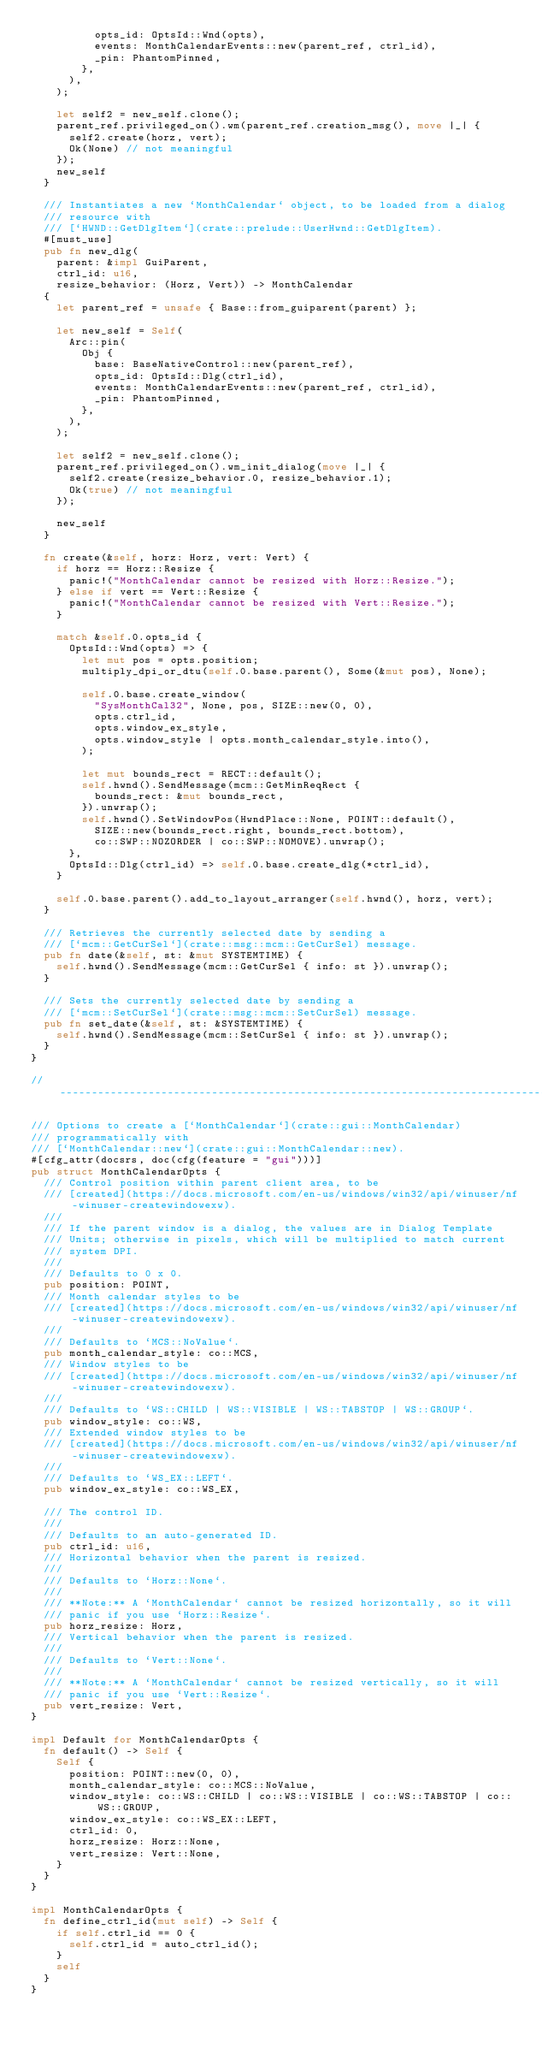<code> <loc_0><loc_0><loc_500><loc_500><_Rust_>					opts_id: OptsId::Wnd(opts),
					events: MonthCalendarEvents::new(parent_ref, ctrl_id),
					_pin: PhantomPinned,
				},
			),
		);

		let self2 = new_self.clone();
		parent_ref.privileged_on().wm(parent_ref.creation_msg(), move |_| {
			self2.create(horz, vert);
			Ok(None) // not meaningful
		});
		new_self
	}

	/// Instantiates a new `MonthCalendar` object, to be loaded from a dialog
	/// resource with
	/// [`HWND::GetDlgItem`](crate::prelude::UserHwnd::GetDlgItem).
	#[must_use]
	pub fn new_dlg(
		parent: &impl GuiParent,
		ctrl_id: u16,
		resize_behavior: (Horz, Vert)) -> MonthCalendar
	{
		let parent_ref = unsafe { Base::from_guiparent(parent) };

		let new_self = Self(
			Arc::pin(
				Obj {
					base: BaseNativeControl::new(parent_ref),
					opts_id: OptsId::Dlg(ctrl_id),
					events: MonthCalendarEvents::new(parent_ref, ctrl_id),
					_pin: PhantomPinned,
				},
			),
		);

		let self2 = new_self.clone();
		parent_ref.privileged_on().wm_init_dialog(move |_| {
			self2.create(resize_behavior.0, resize_behavior.1);
			Ok(true) // not meaningful
		});

		new_self
	}

	fn create(&self, horz: Horz, vert: Vert) {
		if horz == Horz::Resize {
			panic!("MonthCalendar cannot be resized with Horz::Resize.");
		} else if vert == Vert::Resize {
			panic!("MonthCalendar cannot be resized with Vert::Resize.");
		}

		match &self.0.opts_id {
			OptsId::Wnd(opts) => {
				let mut pos = opts.position;
				multiply_dpi_or_dtu(self.0.base.parent(), Some(&mut pos), None);

				self.0.base.create_window(
					"SysMonthCal32", None, pos, SIZE::new(0, 0),
					opts.ctrl_id,
					opts.window_ex_style,
					opts.window_style | opts.month_calendar_style.into(),
				);

				let mut bounds_rect = RECT::default();
				self.hwnd().SendMessage(mcm::GetMinReqRect {
					bounds_rect: &mut bounds_rect,
				}).unwrap();
				self.hwnd().SetWindowPos(HwndPlace::None, POINT::default(),
					SIZE::new(bounds_rect.right, bounds_rect.bottom),
					co::SWP::NOZORDER | co::SWP::NOMOVE).unwrap();
			},
			OptsId::Dlg(ctrl_id) => self.0.base.create_dlg(*ctrl_id),
		}

		self.0.base.parent().add_to_layout_arranger(self.hwnd(), horz, vert);
	}

	/// Retrieves the currently selected date by sending a
	/// [`mcm::GetCurSel`](crate::msg::mcm::GetCurSel) message.
	pub fn date(&self, st: &mut SYSTEMTIME) {
		self.hwnd().SendMessage(mcm::GetCurSel { info: st }).unwrap();
	}

	/// Sets the currently selected date by sending a
	/// [`mcm::SetCurSel`](crate::msg::mcm::SetCurSel) message.
	pub fn set_date(&self, st: &SYSTEMTIME) {
		self.hwnd().SendMessage(mcm::SetCurSel { info: st }).unwrap();
	}
}

//------------------------------------------------------------------------------

/// Options to create a [`MonthCalendar`](crate::gui::MonthCalendar)
/// programmatically with
/// [`MonthCalendar::new`](crate::gui::MonthCalendar::new).
#[cfg_attr(docsrs, doc(cfg(feature = "gui")))]
pub struct MonthCalendarOpts {
	/// Control position within parent client area, to be
	/// [created](https://docs.microsoft.com/en-us/windows/win32/api/winuser/nf-winuser-createwindowexw).
	///
	/// If the parent window is a dialog, the values are in Dialog Template
	/// Units; otherwise in pixels, which will be multiplied to match current
	/// system DPI.
	///
	/// Defaults to 0 x 0.
	pub position: POINT,
	/// Month calendar styles to be
	/// [created](https://docs.microsoft.com/en-us/windows/win32/api/winuser/nf-winuser-createwindowexw).
	///
	/// Defaults to `MCS::NoValue`.
	pub month_calendar_style: co::MCS,
	/// Window styles to be
	/// [created](https://docs.microsoft.com/en-us/windows/win32/api/winuser/nf-winuser-createwindowexw).
	///
	/// Defaults to `WS::CHILD | WS::VISIBLE | WS::TABSTOP | WS::GROUP`.
	pub window_style: co::WS,
	/// Extended window styles to be
	/// [created](https://docs.microsoft.com/en-us/windows/win32/api/winuser/nf-winuser-createwindowexw).
	///
	/// Defaults to `WS_EX::LEFT`.
	pub window_ex_style: co::WS_EX,

	/// The control ID.
	///
	/// Defaults to an auto-generated ID.
	pub ctrl_id: u16,
	/// Horizontal behavior when the parent is resized.
	///
	/// Defaults to `Horz::None`.
	///
	/// **Note:** A `MonthCalendar` cannot be resized horizontally, so it will
	/// panic if you use `Horz::Resize`.
	pub horz_resize: Horz,
	/// Vertical behavior when the parent is resized.
	///
	/// Defaults to `Vert::None`.
	///
	/// **Note:** A `MonthCalendar` cannot be resized vertically, so it will
	/// panic if you use `Vert::Resize`.
	pub vert_resize: Vert,
}

impl Default for MonthCalendarOpts {
	fn default() -> Self {
		Self {
			position: POINT::new(0, 0),
			month_calendar_style: co::MCS::NoValue,
			window_style: co::WS::CHILD | co::WS::VISIBLE | co::WS::TABSTOP | co::WS::GROUP,
			window_ex_style: co::WS_EX::LEFT,
			ctrl_id: 0,
			horz_resize: Horz::None,
			vert_resize: Vert::None,
		}
	}
}

impl MonthCalendarOpts {
	fn define_ctrl_id(mut self) -> Self {
		if self.ctrl_id == 0 {
			self.ctrl_id = auto_ctrl_id();
		}
		self
	}
}
</code> 